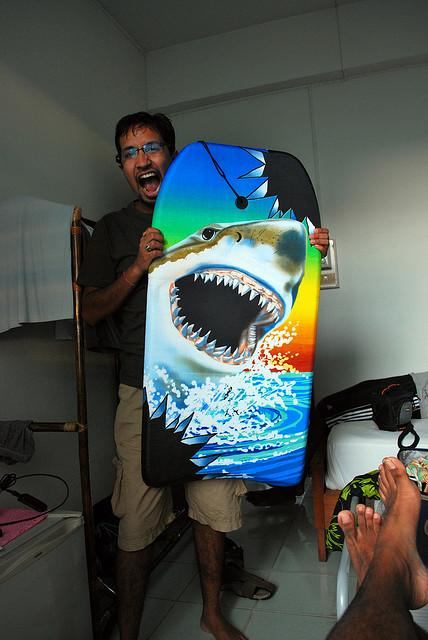What water sport is the object the man is holding used in?

Choices:
A) wakeboarding
B) windsurfing
C) surfing
D) bodyboarding bodyboarding 